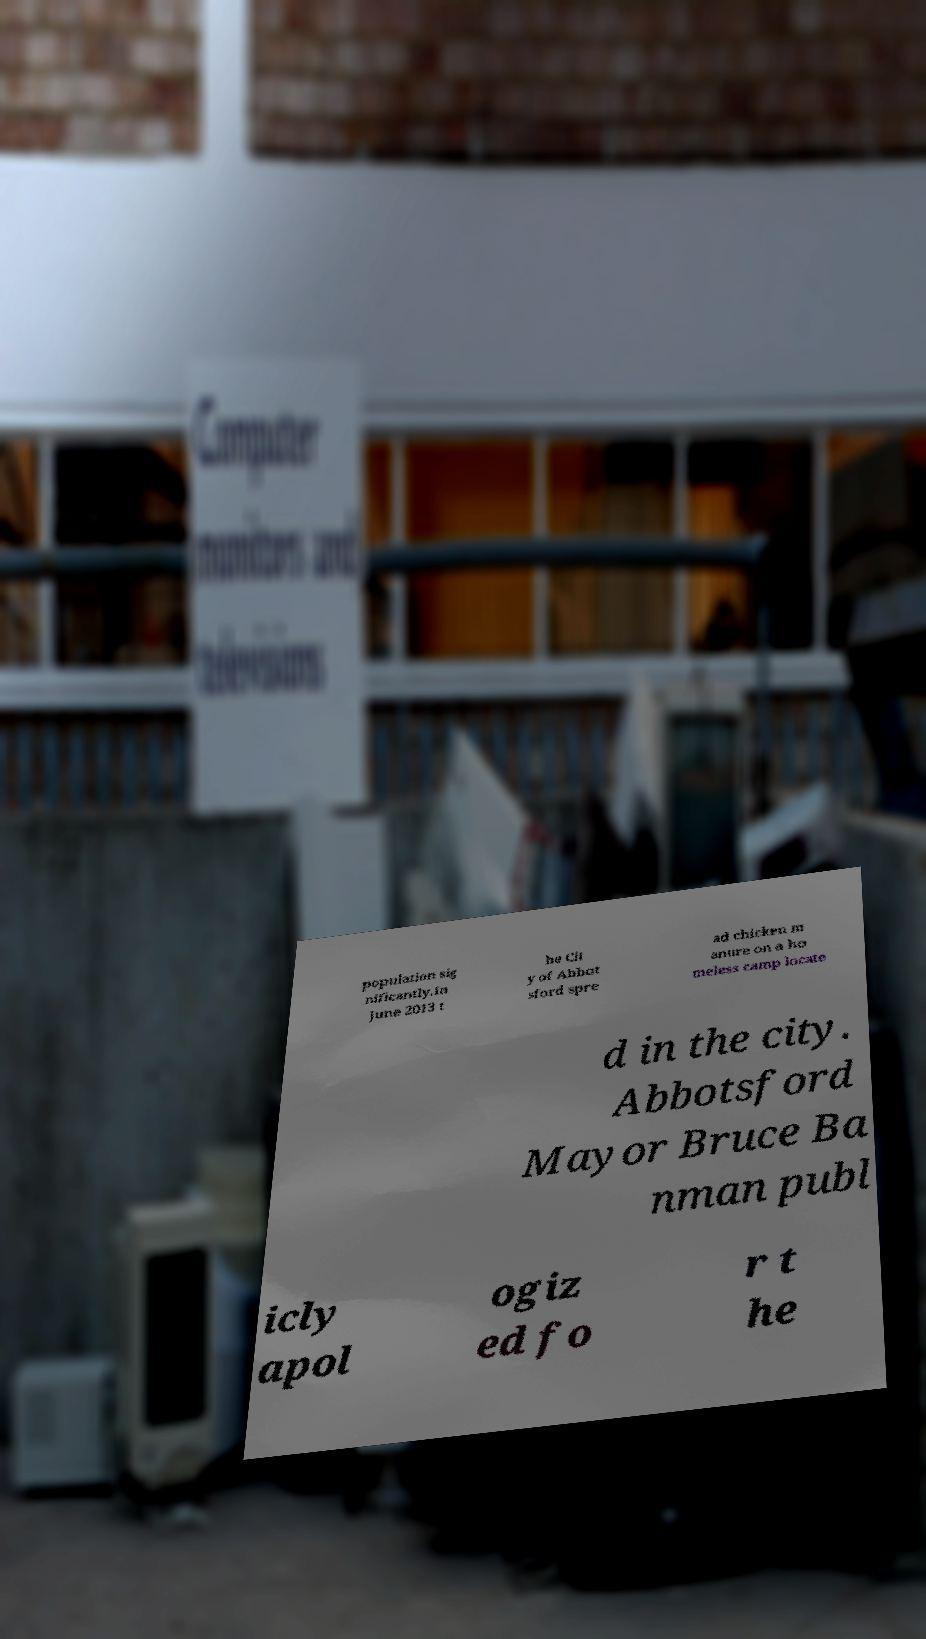Please read and relay the text visible in this image. What does it say? population sig nificantly.In June 2013 t he Cit y of Abbot sford spre ad chicken m anure on a ho meless camp locate d in the city. Abbotsford Mayor Bruce Ba nman publ icly apol ogiz ed fo r t he 